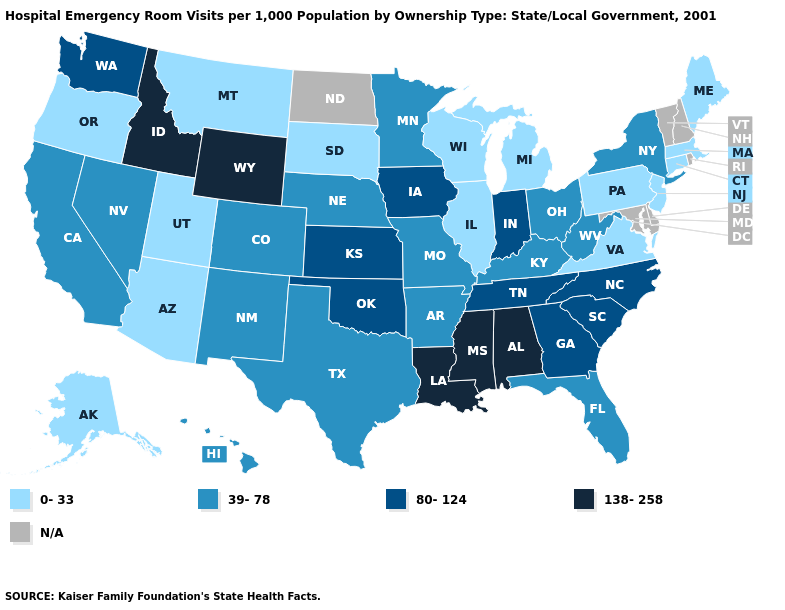What is the lowest value in the USA?
Give a very brief answer. 0-33. Does the first symbol in the legend represent the smallest category?
Be succinct. Yes. Is the legend a continuous bar?
Quick response, please. No. Among the states that border New Jersey , which have the lowest value?
Answer briefly. Pennsylvania. What is the value of New Mexico?
Short answer required. 39-78. Name the states that have a value in the range N/A?
Be succinct. Delaware, Maryland, New Hampshire, North Dakota, Rhode Island, Vermont. Does Kansas have the highest value in the MidWest?
Keep it brief. Yes. Is the legend a continuous bar?
Quick response, please. No. Which states have the lowest value in the MidWest?
Keep it brief. Illinois, Michigan, South Dakota, Wisconsin. Name the states that have a value in the range N/A?
Answer briefly. Delaware, Maryland, New Hampshire, North Dakota, Rhode Island, Vermont. What is the value of Iowa?
Quick response, please. 80-124. What is the value of New Jersey?
Answer briefly. 0-33. Does the map have missing data?
Quick response, please. Yes. Does Pennsylvania have the lowest value in the USA?
Short answer required. Yes. 